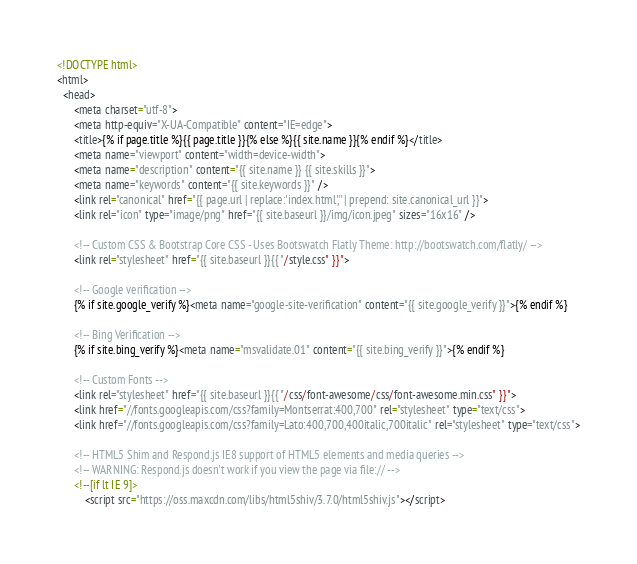<code> <loc_0><loc_0><loc_500><loc_500><_HTML_><!DOCTYPE html>
<html>
  <head>
      <meta charset="utf-8">
      <meta http-equiv="X-UA-Compatible" content="IE=edge">
      <title>{% if page.title %}{{ page.title }}{% else %}{{ site.name }}{% endif %}</title>
      <meta name="viewport" content="width=device-width">
      <meta name="description" content="{{ site.name }} {{ site.skills }}">
      <meta name="keywords" content="{{ site.keywords }}" />
      <link rel="canonical" href="{{ page.url | replace:'index.html','' | prepend: site.canonical_url }}">
      <link rel="icon" type="image/png" href="{{ site.baseurl }}/img/icon.jpeg" sizes="16x16" />

      <!-- Custom CSS & Bootstrap Core CSS - Uses Bootswatch Flatly Theme: http://bootswatch.com/flatly/ -->
      <link rel="stylesheet" href="{{ site.baseurl }}{{ "/style.css" }}">

      <!-- Google verification -->
      {% if site.google_verify %}<meta name="google-site-verification" content="{{ site.google_verify }}">{% endif %}

      <!-- Bing Verification -->
      {% if site.bing_verify %}<meta name="msvalidate.01" content="{{ site.bing_verify }}">{% endif %}

      <!-- Custom Fonts -->
      <link rel="stylesheet" href="{{ site.baseurl }}{{ "/css/font-awesome/css/font-awesome.min.css" }}">
      <link href="//fonts.googleapis.com/css?family=Montserrat:400,700" rel="stylesheet" type="text/css">
      <link href="//fonts.googleapis.com/css?family=Lato:400,700,400italic,700italic" rel="stylesheet" type="text/css">

      <!-- HTML5 Shim and Respond.js IE8 support of HTML5 elements and media queries -->
      <!-- WARNING: Respond.js doesn't work if you view the page via file:// -->
      <!--[if lt IE 9]>
          <script src="https://oss.maxcdn.com/libs/html5shiv/3.7.0/html5shiv.js"></script></code> 